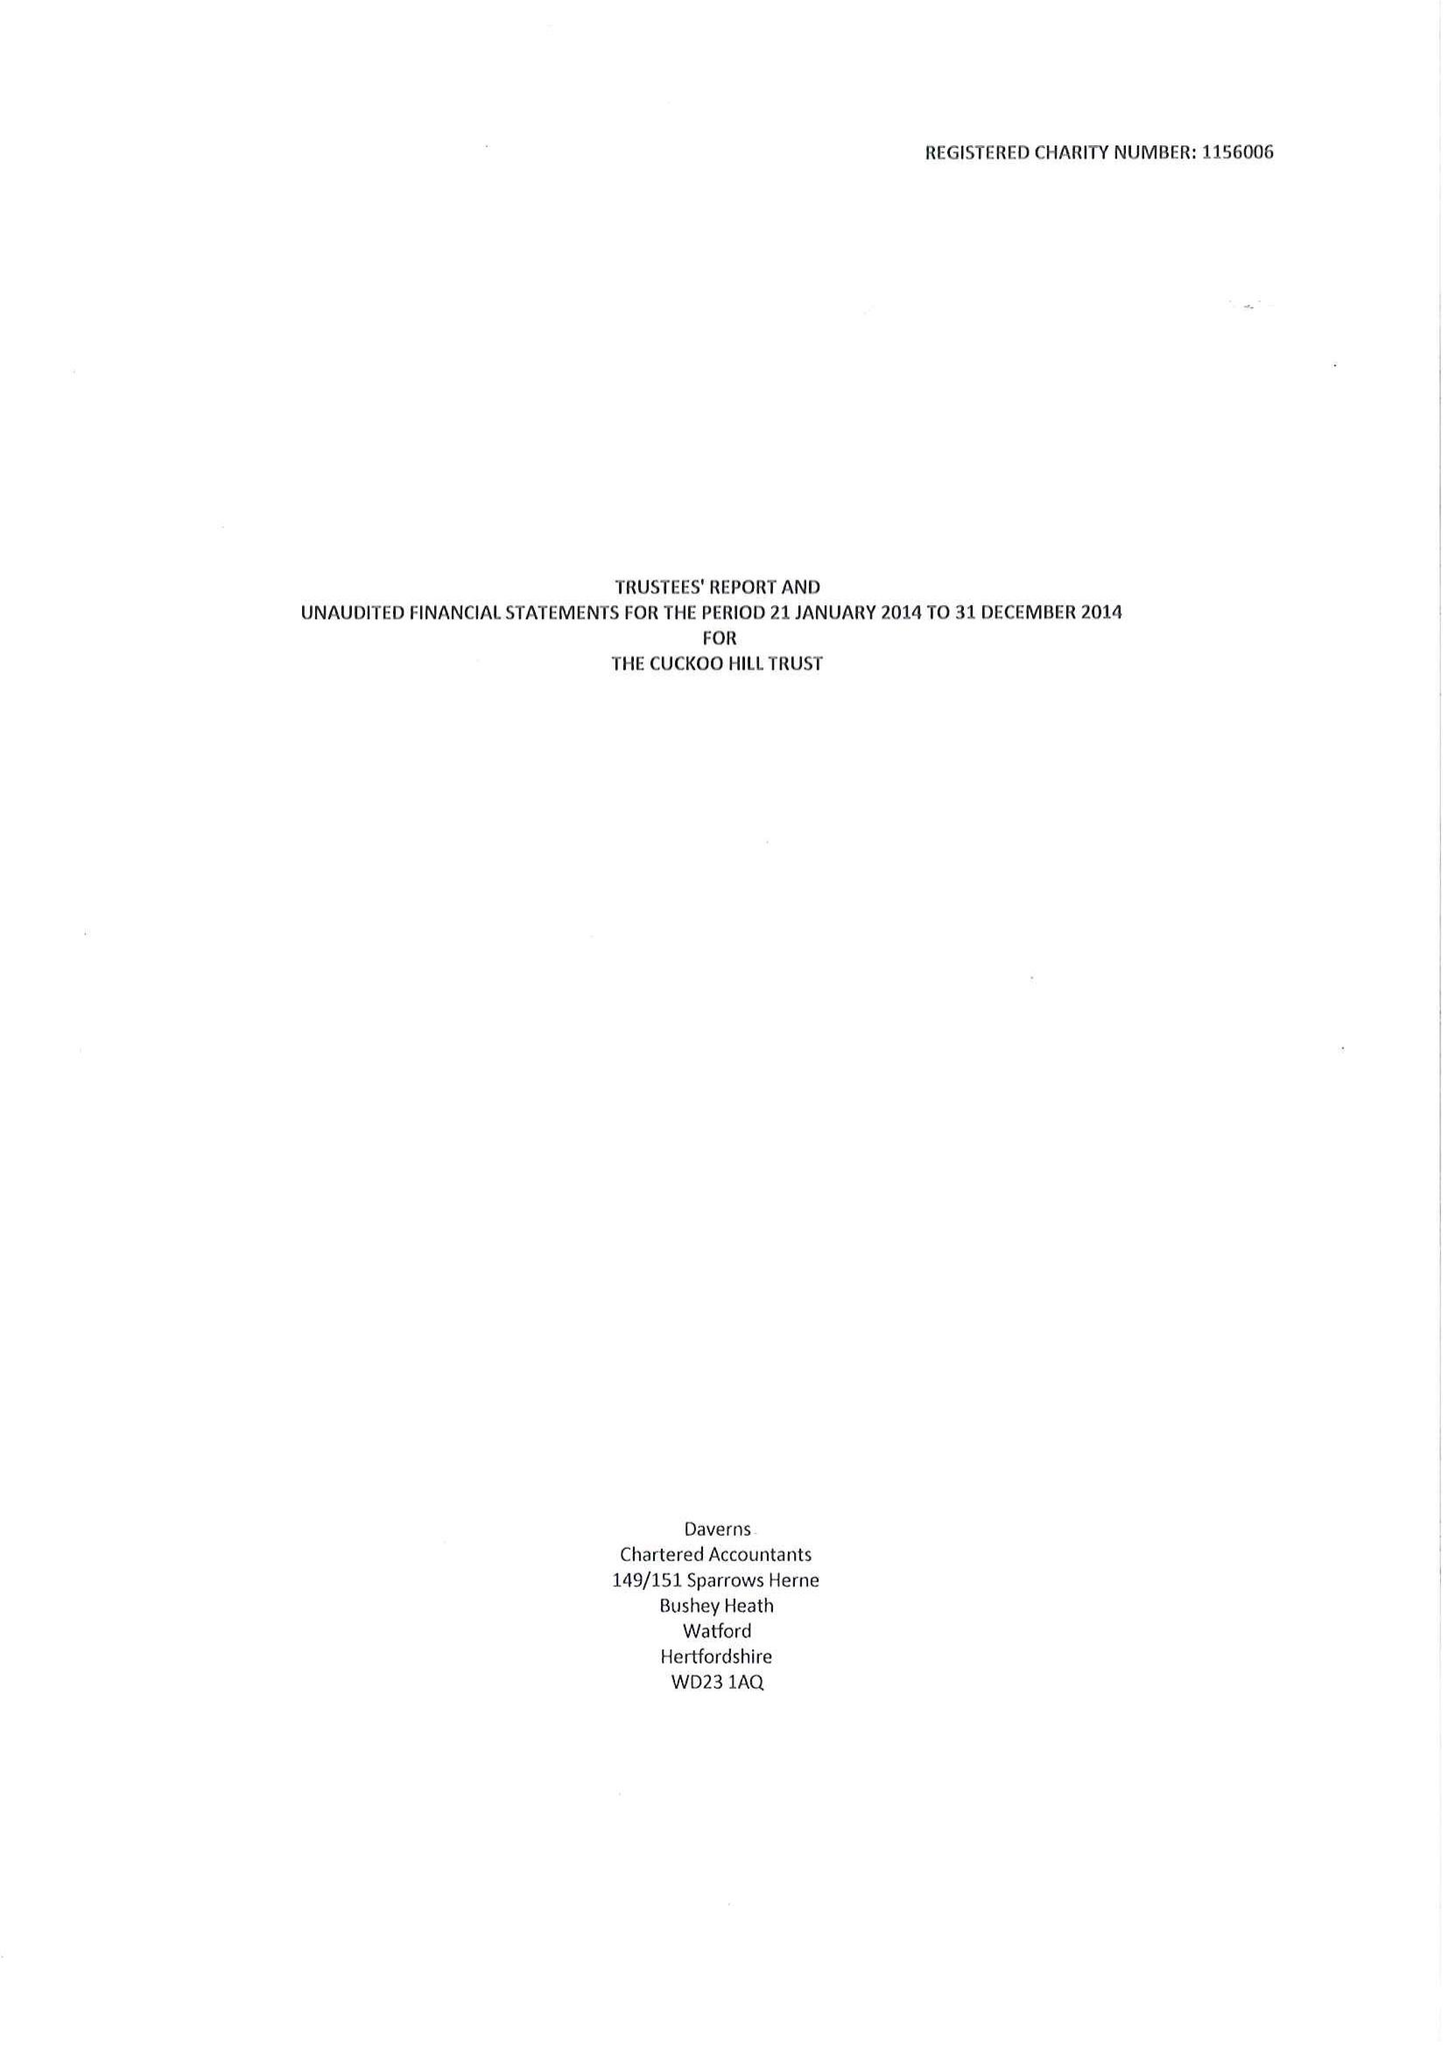What is the value for the charity_name?
Answer the question using a single word or phrase. The Cuckoo Hill Trust 